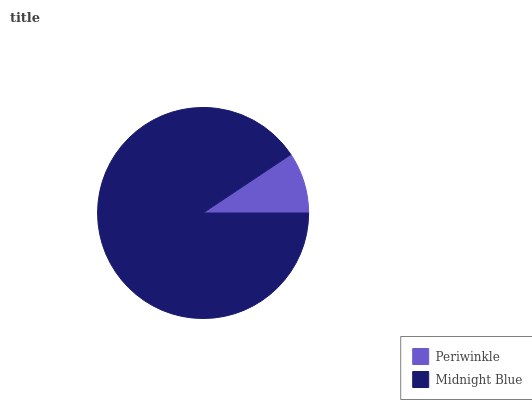Is Periwinkle the minimum?
Answer yes or no. Yes. Is Midnight Blue the maximum?
Answer yes or no. Yes. Is Midnight Blue the minimum?
Answer yes or no. No. Is Midnight Blue greater than Periwinkle?
Answer yes or no. Yes. Is Periwinkle less than Midnight Blue?
Answer yes or no. Yes. Is Periwinkle greater than Midnight Blue?
Answer yes or no. No. Is Midnight Blue less than Periwinkle?
Answer yes or no. No. Is Midnight Blue the high median?
Answer yes or no. Yes. Is Periwinkle the low median?
Answer yes or no. Yes. Is Periwinkle the high median?
Answer yes or no. No. Is Midnight Blue the low median?
Answer yes or no. No. 